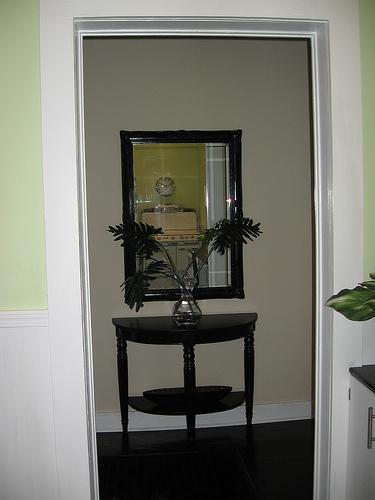How many people are standing front of the mirror?
Give a very brief answer. 0. 